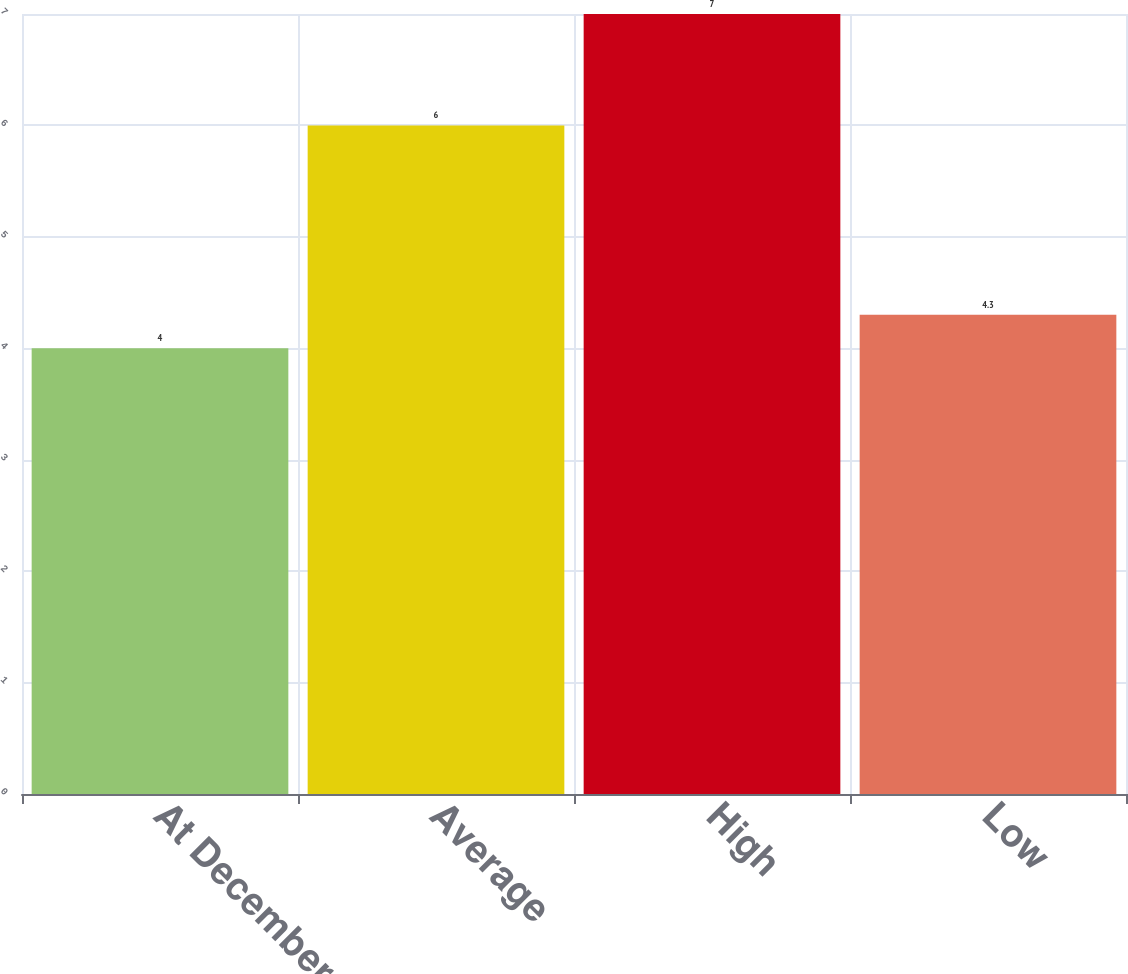Convert chart. <chart><loc_0><loc_0><loc_500><loc_500><bar_chart><fcel>At December 31<fcel>Average<fcel>High<fcel>Low<nl><fcel>4<fcel>6<fcel>7<fcel>4.3<nl></chart> 